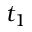<formula> <loc_0><loc_0><loc_500><loc_500>t _ { 1 }</formula> 